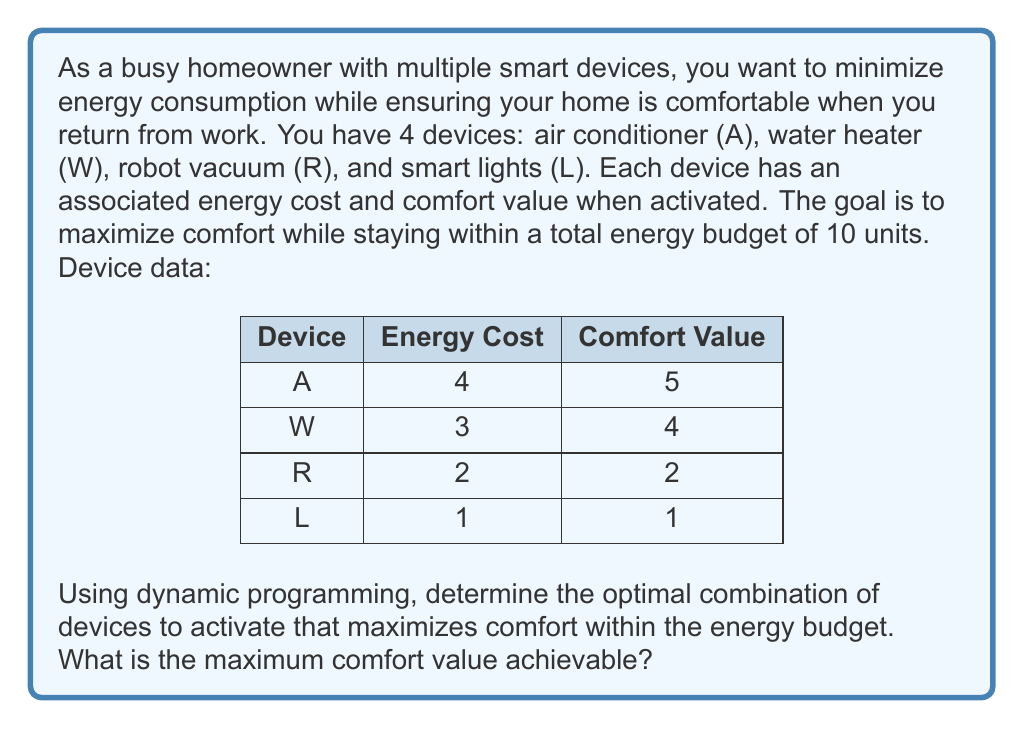What is the answer to this math problem? To solve this problem using dynamic programming, we'll create a table where rows represent devices and columns represent energy budgets from 0 to 10. Each cell will contain the maximum comfort value achievable with the given energy budget and available devices.

Let's build the table step by step:

1. Initialize the table with zeros:
   $$
   \begin{array}{|c|c|c|c|c|c|c|c|c|c|c|c|}
   \hline
   \text{Device} & 0 & 1 & 2 & 3 & 4 & 5 & 6 & 7 & 8 & 9 & 10 \\
   \hline
   L & 0 & 0 & 0 & 0 & 0 & 0 & 0 & 0 & 0 & 0 & 0 \\
   R & 0 & 0 & 0 & 0 & 0 & 0 & 0 & 0 & 0 & 0 & 0 \\
   W & 0 & 0 & 0 & 0 & 0 & 0 & 0 & 0 & 0 & 0 & 0 \\
   A & 0 & 0 & 0 & 0 & 0 & 0 & 0 & 0 & 0 & 0 & 0 \\
   \hline
   \end{array}
   $$

2. Fill the table for device L (smart lights):
   - For energy budget 1 and above, we can use L, so we add its comfort value (1).
   $$
   \begin{array}{|c|c|c|c|c|c|c|c|c|c|c|c|}
   \hline
   \text{Device} & 0 & 1 & 2 & 3 & 4 & 5 & 6 & 7 & 8 & 9 & 10 \\
   \hline
   L & 0 & 1 & 1 & 1 & 1 & 1 & 1 & 1 & 1 & 1 & 1 \\
   R & 0 & 0 & 0 & 0 & 0 & 0 & 0 & 0 & 0 & 0 & 0 \\
   W & 0 & 0 & 0 & 0 & 0 & 0 & 0 & 0 & 0 & 0 & 0 \\
   A & 0 & 0 & 0 & 0 & 0 & 0 & 0 & 0 & 0 & 0 & 0 \\
   \hline
   \end{array}
   $$

3. Fill the table for device R (robot vacuum):
   - For energy budget 2 and above, we can use R. We compare using R vs. not using R and take the maximum.
   $$
   \begin{array}{|c|c|c|c|c|c|c|c|c|c|c|c|}
   \hline
   \text{Device} & 0 & 1 & 2 & 3 & 4 & 5 & 6 & 7 & 8 & 9 & 10 \\
   \hline
   L & 0 & 1 & 1 & 1 & 1 & 1 & 1 & 1 & 1 & 1 & 1 \\
   R & 0 & 1 & 2 & 3 & 3 & 3 & 3 & 3 & 3 & 3 & 3 \\
   W & 0 & 0 & 0 & 0 & 0 & 0 & 0 & 0 & 0 & 0 & 0 \\
   A & 0 & 0 & 0 & 0 & 0 & 0 & 0 & 0 & 0 & 0 & 0 \\
   \hline
   \end{array}
   $$

4. Fill the table for device W (water heater):
   - For energy budget 3 and above, we can use W. We compare using W vs. not using W and take the maximum.
   $$
   \begin{array}{|c|c|c|c|c|c|c|c|c|c|c|c|}
   \hline
   \text{Device} & 0 & 1 & 2 & 3 & 4 & 5 & 6 & 7 & 8 & 9 & 10 \\
   \hline
   L & 0 & 1 & 1 & 1 & 1 & 1 & 1 & 1 & 1 & 1 & 1 \\
   R & 0 & 1 & 2 & 3 & 3 & 3 & 3 & 3 & 3 & 3 & 3 \\
   W & 0 & 1 & 2 & 4 & 5 & 6 & 7 & 7 & 7 & 7 & 7 \\
   A & 0 & 0 & 0 & 0 & 0 & 0 & 0 & 0 & 0 & 0 & 0 \\
   \hline
   \end{array}
   $$

5. Fill the table for device A (air conditioner):
   - For energy budget 4 and above, we can use A. We compare using A vs. not using A and take the maximum.
   $$
   \begin{array}{|c|c|c|c|c|c|c|c|c|c|c|c|}
   \hline
   \text{Device} & 0 & 1 & 2 & 3 & 4 & 5 & 6 & 7 & 8 & 9 & 10 \\
   \hline
   L & 0 & 1 & 1 & 1 & 1 & 1 & 1 & 1 & 1 & 1 & 1 \\
   R & 0 & 1 & 2 & 3 & 3 & 3 & 3 & 3 & 3 & 3 & 3 \\
   W & 0 & 1 & 2 & 4 & 5 & 6 & 7 & 7 & 7 & 7 & 7 \\
   A & 0 & 1 & 2 & 4 & 5 & 6 & 7 & 8 & 9 & 10 & 11 \\
   \hline
   \end{array}
   $$

The maximum comfort value achievable within the energy budget of 10 units is 11, which is found in the last cell of the table.
Answer: 11 